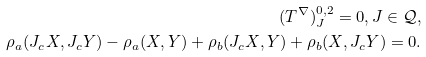<formula> <loc_0><loc_0><loc_500><loc_500>( T ^ { \nabla } ) ^ { 0 , 2 } _ { J } = 0 , J \in \mathcal { Q } , \\ \rho _ { a } ( J _ { c } X , J _ { c } Y ) - \rho _ { a } ( X , Y ) + \rho _ { b } ( J _ { c } X , Y ) + \rho _ { b } ( X , J _ { c } Y ) = 0 .</formula> 